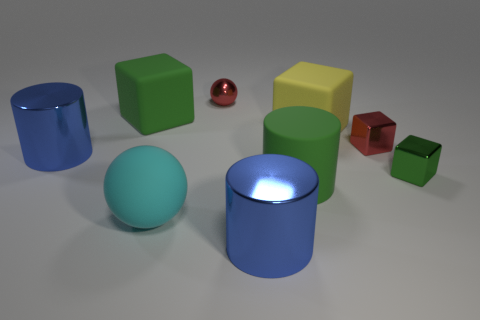There is a sphere in front of the sphere behind the cylinder that is behind the large green cylinder; what size is it?
Provide a succinct answer. Large. Does the cyan rubber thing have the same size as the red thing that is in front of the large yellow rubber object?
Provide a short and direct response. No. Are there fewer things to the right of the metal sphere than green matte blocks?
Your response must be concise. No. What number of metallic cylinders are the same color as the big ball?
Provide a succinct answer. 0. Are there fewer red shiny spheres than green metal balls?
Provide a short and direct response. No. Do the large green cube and the big cyan thing have the same material?
Make the answer very short. Yes. How many other objects are the same size as the yellow matte block?
Provide a short and direct response. 5. What color is the cylinder that is on the left side of the large blue metallic cylinder in front of the tiny green shiny object?
Make the answer very short. Blue. How many other things are there of the same shape as the yellow rubber thing?
Make the answer very short. 3. Are there any large green balls made of the same material as the tiny green thing?
Give a very brief answer. No. 